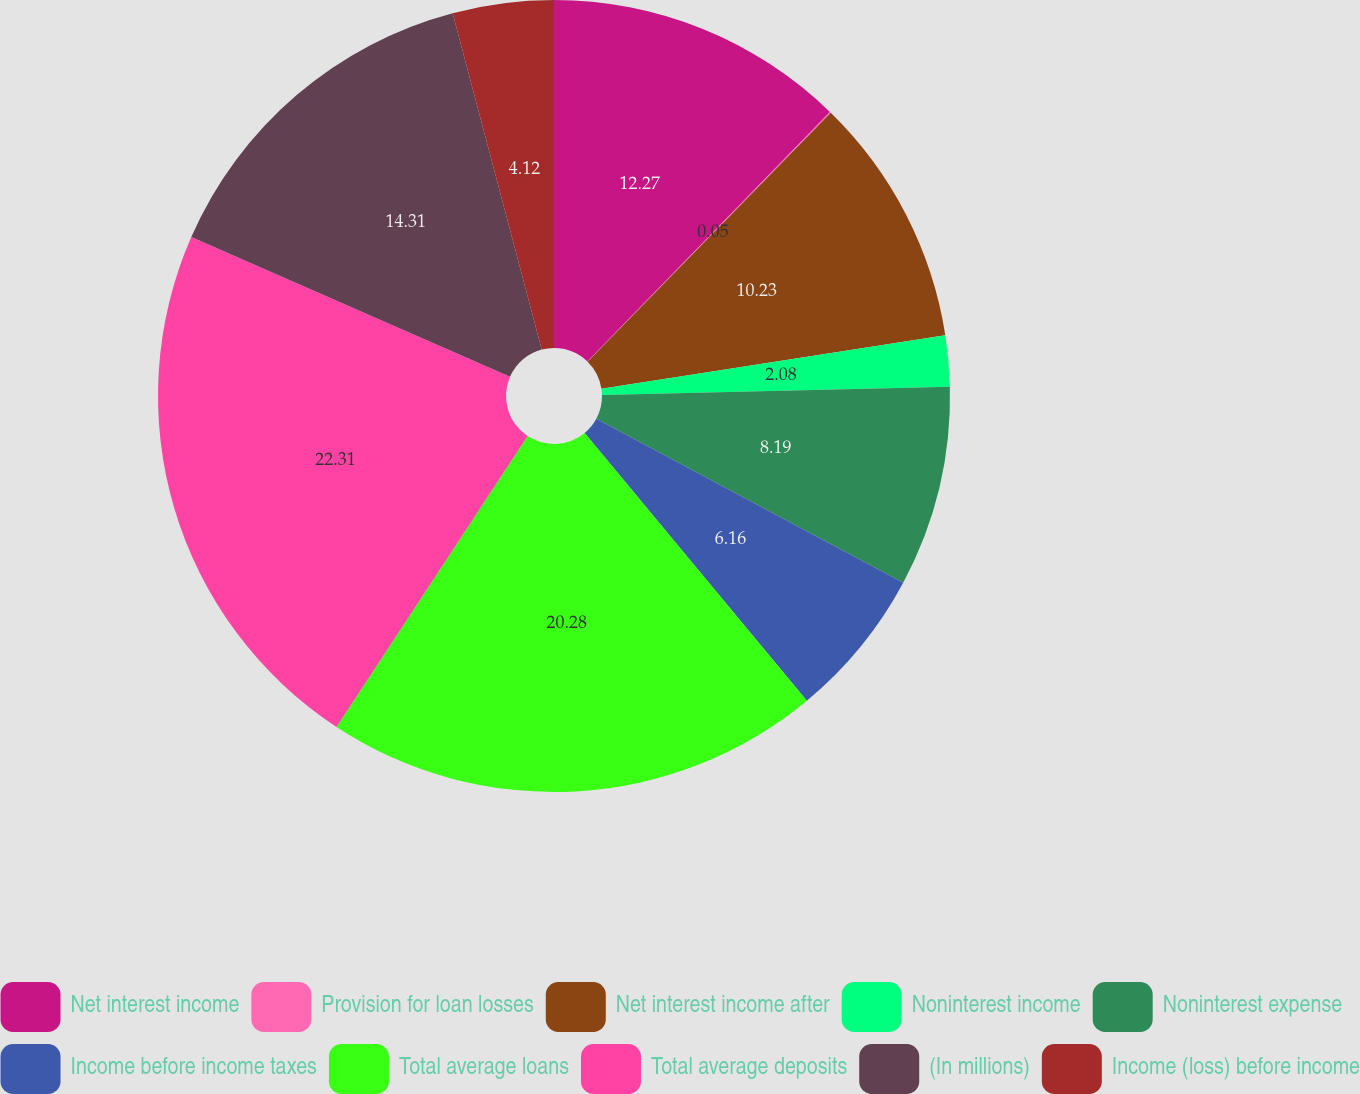Convert chart to OTSL. <chart><loc_0><loc_0><loc_500><loc_500><pie_chart><fcel>Net interest income<fcel>Provision for loan losses<fcel>Net interest income after<fcel>Noninterest income<fcel>Noninterest expense<fcel>Income before income taxes<fcel>Total average loans<fcel>Total average deposits<fcel>(In millions)<fcel>Income (loss) before income<nl><fcel>12.27%<fcel>0.05%<fcel>10.23%<fcel>2.08%<fcel>8.19%<fcel>6.16%<fcel>20.28%<fcel>22.32%<fcel>14.31%<fcel>4.12%<nl></chart> 